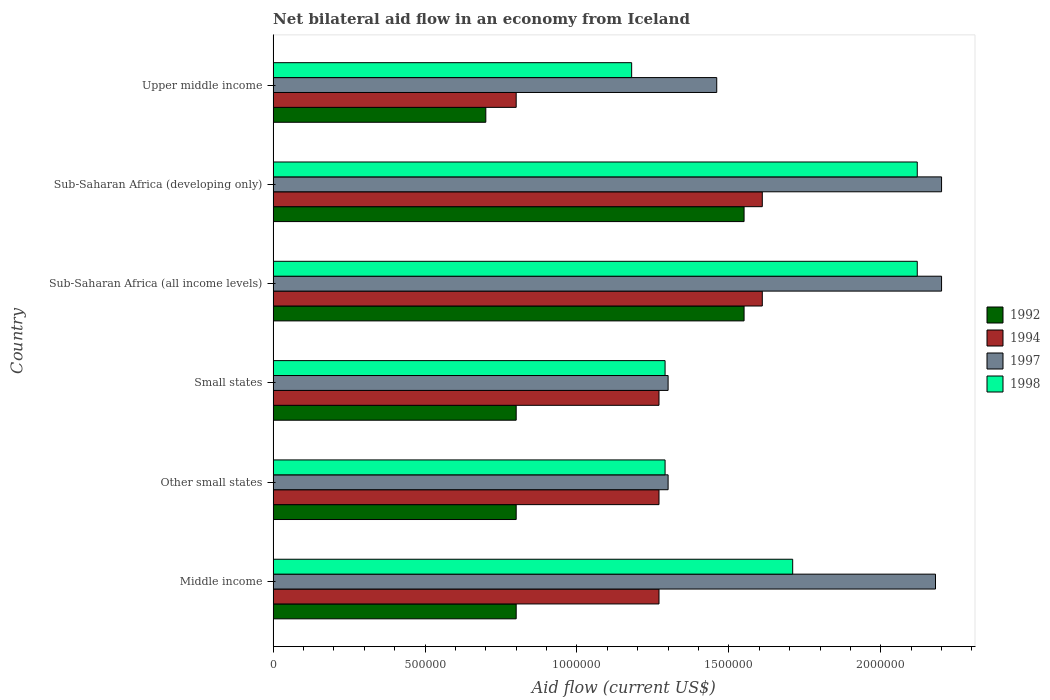How many different coloured bars are there?
Offer a terse response. 4. How many groups of bars are there?
Keep it short and to the point. 6. How many bars are there on the 2nd tick from the top?
Your response must be concise. 4. What is the label of the 6th group of bars from the top?
Your answer should be compact. Middle income. What is the net bilateral aid flow in 1998 in Other small states?
Your answer should be compact. 1.29e+06. Across all countries, what is the maximum net bilateral aid flow in 1994?
Your answer should be very brief. 1.61e+06. In which country was the net bilateral aid flow in 1998 maximum?
Your answer should be very brief. Sub-Saharan Africa (all income levels). In which country was the net bilateral aid flow in 1997 minimum?
Offer a very short reply. Other small states. What is the total net bilateral aid flow in 1998 in the graph?
Your answer should be very brief. 9.71e+06. What is the difference between the net bilateral aid flow in 1992 in Middle income and that in Upper middle income?
Keep it short and to the point. 1.00e+05. What is the difference between the net bilateral aid flow in 1994 in Sub-Saharan Africa (developing only) and the net bilateral aid flow in 1992 in Middle income?
Ensure brevity in your answer.  8.10e+05. What is the average net bilateral aid flow in 1994 per country?
Ensure brevity in your answer.  1.30e+06. What is the difference between the net bilateral aid flow in 1992 and net bilateral aid flow in 1998 in Sub-Saharan Africa (all income levels)?
Ensure brevity in your answer.  -5.70e+05. What is the ratio of the net bilateral aid flow in 1997 in Sub-Saharan Africa (developing only) to that in Upper middle income?
Make the answer very short. 1.51. Is the net bilateral aid flow in 1994 in Other small states less than that in Small states?
Offer a very short reply. No. What is the difference between the highest and the lowest net bilateral aid flow in 1992?
Provide a short and direct response. 8.50e+05. Is it the case that in every country, the sum of the net bilateral aid flow in 1994 and net bilateral aid flow in 1992 is greater than the sum of net bilateral aid flow in 1998 and net bilateral aid flow in 1997?
Keep it short and to the point. No. What does the 2nd bar from the top in Sub-Saharan Africa (all income levels) represents?
Provide a succinct answer. 1997. What does the 1st bar from the bottom in Middle income represents?
Your answer should be very brief. 1992. Is it the case that in every country, the sum of the net bilateral aid flow in 1994 and net bilateral aid flow in 1998 is greater than the net bilateral aid flow in 1992?
Keep it short and to the point. Yes. Are the values on the major ticks of X-axis written in scientific E-notation?
Provide a short and direct response. No. How are the legend labels stacked?
Your answer should be compact. Vertical. What is the title of the graph?
Provide a short and direct response. Net bilateral aid flow in an economy from Iceland. What is the label or title of the X-axis?
Your answer should be very brief. Aid flow (current US$). What is the Aid flow (current US$) of 1992 in Middle income?
Provide a succinct answer. 8.00e+05. What is the Aid flow (current US$) of 1994 in Middle income?
Give a very brief answer. 1.27e+06. What is the Aid flow (current US$) of 1997 in Middle income?
Make the answer very short. 2.18e+06. What is the Aid flow (current US$) in 1998 in Middle income?
Your response must be concise. 1.71e+06. What is the Aid flow (current US$) of 1992 in Other small states?
Make the answer very short. 8.00e+05. What is the Aid flow (current US$) of 1994 in Other small states?
Offer a terse response. 1.27e+06. What is the Aid flow (current US$) of 1997 in Other small states?
Offer a terse response. 1.30e+06. What is the Aid flow (current US$) of 1998 in Other small states?
Keep it short and to the point. 1.29e+06. What is the Aid flow (current US$) in 1992 in Small states?
Offer a very short reply. 8.00e+05. What is the Aid flow (current US$) of 1994 in Small states?
Your answer should be very brief. 1.27e+06. What is the Aid flow (current US$) of 1997 in Small states?
Give a very brief answer. 1.30e+06. What is the Aid flow (current US$) of 1998 in Small states?
Make the answer very short. 1.29e+06. What is the Aid flow (current US$) of 1992 in Sub-Saharan Africa (all income levels)?
Ensure brevity in your answer.  1.55e+06. What is the Aid flow (current US$) in 1994 in Sub-Saharan Africa (all income levels)?
Provide a short and direct response. 1.61e+06. What is the Aid flow (current US$) of 1997 in Sub-Saharan Africa (all income levels)?
Make the answer very short. 2.20e+06. What is the Aid flow (current US$) of 1998 in Sub-Saharan Africa (all income levels)?
Make the answer very short. 2.12e+06. What is the Aid flow (current US$) of 1992 in Sub-Saharan Africa (developing only)?
Offer a terse response. 1.55e+06. What is the Aid flow (current US$) in 1994 in Sub-Saharan Africa (developing only)?
Offer a terse response. 1.61e+06. What is the Aid flow (current US$) in 1997 in Sub-Saharan Africa (developing only)?
Your response must be concise. 2.20e+06. What is the Aid flow (current US$) in 1998 in Sub-Saharan Africa (developing only)?
Ensure brevity in your answer.  2.12e+06. What is the Aid flow (current US$) of 1994 in Upper middle income?
Make the answer very short. 8.00e+05. What is the Aid flow (current US$) in 1997 in Upper middle income?
Offer a very short reply. 1.46e+06. What is the Aid flow (current US$) in 1998 in Upper middle income?
Provide a short and direct response. 1.18e+06. Across all countries, what is the maximum Aid flow (current US$) of 1992?
Your answer should be very brief. 1.55e+06. Across all countries, what is the maximum Aid flow (current US$) in 1994?
Ensure brevity in your answer.  1.61e+06. Across all countries, what is the maximum Aid flow (current US$) of 1997?
Provide a succinct answer. 2.20e+06. Across all countries, what is the maximum Aid flow (current US$) of 1998?
Your answer should be very brief. 2.12e+06. Across all countries, what is the minimum Aid flow (current US$) of 1992?
Your answer should be very brief. 7.00e+05. Across all countries, what is the minimum Aid flow (current US$) of 1997?
Make the answer very short. 1.30e+06. Across all countries, what is the minimum Aid flow (current US$) of 1998?
Your answer should be very brief. 1.18e+06. What is the total Aid flow (current US$) of 1992 in the graph?
Make the answer very short. 6.20e+06. What is the total Aid flow (current US$) in 1994 in the graph?
Ensure brevity in your answer.  7.83e+06. What is the total Aid flow (current US$) in 1997 in the graph?
Offer a terse response. 1.06e+07. What is the total Aid flow (current US$) in 1998 in the graph?
Give a very brief answer. 9.71e+06. What is the difference between the Aid flow (current US$) of 1994 in Middle income and that in Other small states?
Make the answer very short. 0. What is the difference between the Aid flow (current US$) in 1997 in Middle income and that in Other small states?
Give a very brief answer. 8.80e+05. What is the difference between the Aid flow (current US$) in 1998 in Middle income and that in Other small states?
Offer a terse response. 4.20e+05. What is the difference between the Aid flow (current US$) in 1992 in Middle income and that in Small states?
Your response must be concise. 0. What is the difference between the Aid flow (current US$) in 1997 in Middle income and that in Small states?
Ensure brevity in your answer.  8.80e+05. What is the difference between the Aid flow (current US$) in 1992 in Middle income and that in Sub-Saharan Africa (all income levels)?
Your answer should be compact. -7.50e+05. What is the difference between the Aid flow (current US$) of 1998 in Middle income and that in Sub-Saharan Africa (all income levels)?
Provide a short and direct response. -4.10e+05. What is the difference between the Aid flow (current US$) in 1992 in Middle income and that in Sub-Saharan Africa (developing only)?
Provide a succinct answer. -7.50e+05. What is the difference between the Aid flow (current US$) in 1997 in Middle income and that in Sub-Saharan Africa (developing only)?
Provide a succinct answer. -2.00e+04. What is the difference between the Aid flow (current US$) in 1998 in Middle income and that in Sub-Saharan Africa (developing only)?
Your answer should be very brief. -4.10e+05. What is the difference between the Aid flow (current US$) in 1992 in Middle income and that in Upper middle income?
Give a very brief answer. 1.00e+05. What is the difference between the Aid flow (current US$) in 1994 in Middle income and that in Upper middle income?
Make the answer very short. 4.70e+05. What is the difference between the Aid flow (current US$) in 1997 in Middle income and that in Upper middle income?
Provide a short and direct response. 7.20e+05. What is the difference between the Aid flow (current US$) of 1998 in Middle income and that in Upper middle income?
Ensure brevity in your answer.  5.30e+05. What is the difference between the Aid flow (current US$) of 1992 in Other small states and that in Small states?
Your answer should be very brief. 0. What is the difference between the Aid flow (current US$) in 1997 in Other small states and that in Small states?
Your answer should be compact. 0. What is the difference between the Aid flow (current US$) of 1998 in Other small states and that in Small states?
Keep it short and to the point. 0. What is the difference between the Aid flow (current US$) of 1992 in Other small states and that in Sub-Saharan Africa (all income levels)?
Provide a short and direct response. -7.50e+05. What is the difference between the Aid flow (current US$) in 1994 in Other small states and that in Sub-Saharan Africa (all income levels)?
Provide a succinct answer. -3.40e+05. What is the difference between the Aid flow (current US$) of 1997 in Other small states and that in Sub-Saharan Africa (all income levels)?
Ensure brevity in your answer.  -9.00e+05. What is the difference between the Aid flow (current US$) of 1998 in Other small states and that in Sub-Saharan Africa (all income levels)?
Offer a very short reply. -8.30e+05. What is the difference between the Aid flow (current US$) of 1992 in Other small states and that in Sub-Saharan Africa (developing only)?
Your answer should be compact. -7.50e+05. What is the difference between the Aid flow (current US$) of 1997 in Other small states and that in Sub-Saharan Africa (developing only)?
Provide a short and direct response. -9.00e+05. What is the difference between the Aid flow (current US$) in 1998 in Other small states and that in Sub-Saharan Africa (developing only)?
Ensure brevity in your answer.  -8.30e+05. What is the difference between the Aid flow (current US$) of 1997 in Other small states and that in Upper middle income?
Offer a very short reply. -1.60e+05. What is the difference between the Aid flow (current US$) in 1992 in Small states and that in Sub-Saharan Africa (all income levels)?
Offer a very short reply. -7.50e+05. What is the difference between the Aid flow (current US$) of 1994 in Small states and that in Sub-Saharan Africa (all income levels)?
Make the answer very short. -3.40e+05. What is the difference between the Aid flow (current US$) in 1997 in Small states and that in Sub-Saharan Africa (all income levels)?
Keep it short and to the point. -9.00e+05. What is the difference between the Aid flow (current US$) of 1998 in Small states and that in Sub-Saharan Africa (all income levels)?
Ensure brevity in your answer.  -8.30e+05. What is the difference between the Aid flow (current US$) of 1992 in Small states and that in Sub-Saharan Africa (developing only)?
Make the answer very short. -7.50e+05. What is the difference between the Aid flow (current US$) in 1997 in Small states and that in Sub-Saharan Africa (developing only)?
Make the answer very short. -9.00e+05. What is the difference between the Aid flow (current US$) of 1998 in Small states and that in Sub-Saharan Africa (developing only)?
Provide a succinct answer. -8.30e+05. What is the difference between the Aid flow (current US$) of 1994 in Small states and that in Upper middle income?
Your answer should be very brief. 4.70e+05. What is the difference between the Aid flow (current US$) in 1998 in Small states and that in Upper middle income?
Offer a terse response. 1.10e+05. What is the difference between the Aid flow (current US$) in 1994 in Sub-Saharan Africa (all income levels) and that in Sub-Saharan Africa (developing only)?
Provide a short and direct response. 0. What is the difference between the Aid flow (current US$) of 1992 in Sub-Saharan Africa (all income levels) and that in Upper middle income?
Your answer should be compact. 8.50e+05. What is the difference between the Aid flow (current US$) of 1994 in Sub-Saharan Africa (all income levels) and that in Upper middle income?
Your response must be concise. 8.10e+05. What is the difference between the Aid flow (current US$) in 1997 in Sub-Saharan Africa (all income levels) and that in Upper middle income?
Make the answer very short. 7.40e+05. What is the difference between the Aid flow (current US$) of 1998 in Sub-Saharan Africa (all income levels) and that in Upper middle income?
Keep it short and to the point. 9.40e+05. What is the difference between the Aid flow (current US$) of 1992 in Sub-Saharan Africa (developing only) and that in Upper middle income?
Ensure brevity in your answer.  8.50e+05. What is the difference between the Aid flow (current US$) in 1994 in Sub-Saharan Africa (developing only) and that in Upper middle income?
Provide a succinct answer. 8.10e+05. What is the difference between the Aid flow (current US$) in 1997 in Sub-Saharan Africa (developing only) and that in Upper middle income?
Give a very brief answer. 7.40e+05. What is the difference between the Aid flow (current US$) in 1998 in Sub-Saharan Africa (developing only) and that in Upper middle income?
Offer a terse response. 9.40e+05. What is the difference between the Aid flow (current US$) in 1992 in Middle income and the Aid flow (current US$) in 1994 in Other small states?
Ensure brevity in your answer.  -4.70e+05. What is the difference between the Aid flow (current US$) in 1992 in Middle income and the Aid flow (current US$) in 1997 in Other small states?
Ensure brevity in your answer.  -5.00e+05. What is the difference between the Aid flow (current US$) in 1992 in Middle income and the Aid flow (current US$) in 1998 in Other small states?
Ensure brevity in your answer.  -4.90e+05. What is the difference between the Aid flow (current US$) of 1997 in Middle income and the Aid flow (current US$) of 1998 in Other small states?
Offer a very short reply. 8.90e+05. What is the difference between the Aid flow (current US$) of 1992 in Middle income and the Aid flow (current US$) of 1994 in Small states?
Offer a terse response. -4.70e+05. What is the difference between the Aid flow (current US$) of 1992 in Middle income and the Aid flow (current US$) of 1997 in Small states?
Your response must be concise. -5.00e+05. What is the difference between the Aid flow (current US$) of 1992 in Middle income and the Aid flow (current US$) of 1998 in Small states?
Offer a very short reply. -4.90e+05. What is the difference between the Aid flow (current US$) in 1994 in Middle income and the Aid flow (current US$) in 1997 in Small states?
Offer a terse response. -3.00e+04. What is the difference between the Aid flow (current US$) in 1994 in Middle income and the Aid flow (current US$) in 1998 in Small states?
Your answer should be compact. -2.00e+04. What is the difference between the Aid flow (current US$) in 1997 in Middle income and the Aid flow (current US$) in 1998 in Small states?
Your response must be concise. 8.90e+05. What is the difference between the Aid flow (current US$) of 1992 in Middle income and the Aid flow (current US$) of 1994 in Sub-Saharan Africa (all income levels)?
Keep it short and to the point. -8.10e+05. What is the difference between the Aid flow (current US$) of 1992 in Middle income and the Aid flow (current US$) of 1997 in Sub-Saharan Africa (all income levels)?
Ensure brevity in your answer.  -1.40e+06. What is the difference between the Aid flow (current US$) in 1992 in Middle income and the Aid flow (current US$) in 1998 in Sub-Saharan Africa (all income levels)?
Keep it short and to the point. -1.32e+06. What is the difference between the Aid flow (current US$) in 1994 in Middle income and the Aid flow (current US$) in 1997 in Sub-Saharan Africa (all income levels)?
Your response must be concise. -9.30e+05. What is the difference between the Aid flow (current US$) of 1994 in Middle income and the Aid flow (current US$) of 1998 in Sub-Saharan Africa (all income levels)?
Keep it short and to the point. -8.50e+05. What is the difference between the Aid flow (current US$) of 1992 in Middle income and the Aid flow (current US$) of 1994 in Sub-Saharan Africa (developing only)?
Ensure brevity in your answer.  -8.10e+05. What is the difference between the Aid flow (current US$) in 1992 in Middle income and the Aid flow (current US$) in 1997 in Sub-Saharan Africa (developing only)?
Your answer should be compact. -1.40e+06. What is the difference between the Aid flow (current US$) in 1992 in Middle income and the Aid flow (current US$) in 1998 in Sub-Saharan Africa (developing only)?
Your response must be concise. -1.32e+06. What is the difference between the Aid flow (current US$) of 1994 in Middle income and the Aid flow (current US$) of 1997 in Sub-Saharan Africa (developing only)?
Give a very brief answer. -9.30e+05. What is the difference between the Aid flow (current US$) in 1994 in Middle income and the Aid flow (current US$) in 1998 in Sub-Saharan Africa (developing only)?
Keep it short and to the point. -8.50e+05. What is the difference between the Aid flow (current US$) of 1997 in Middle income and the Aid flow (current US$) of 1998 in Sub-Saharan Africa (developing only)?
Make the answer very short. 6.00e+04. What is the difference between the Aid flow (current US$) in 1992 in Middle income and the Aid flow (current US$) in 1997 in Upper middle income?
Keep it short and to the point. -6.60e+05. What is the difference between the Aid flow (current US$) of 1992 in Middle income and the Aid flow (current US$) of 1998 in Upper middle income?
Your response must be concise. -3.80e+05. What is the difference between the Aid flow (current US$) in 1994 in Middle income and the Aid flow (current US$) in 1997 in Upper middle income?
Give a very brief answer. -1.90e+05. What is the difference between the Aid flow (current US$) of 1997 in Middle income and the Aid flow (current US$) of 1998 in Upper middle income?
Offer a very short reply. 1.00e+06. What is the difference between the Aid flow (current US$) of 1992 in Other small states and the Aid flow (current US$) of 1994 in Small states?
Ensure brevity in your answer.  -4.70e+05. What is the difference between the Aid flow (current US$) of 1992 in Other small states and the Aid flow (current US$) of 1997 in Small states?
Provide a succinct answer. -5.00e+05. What is the difference between the Aid flow (current US$) in 1992 in Other small states and the Aid flow (current US$) in 1998 in Small states?
Ensure brevity in your answer.  -4.90e+05. What is the difference between the Aid flow (current US$) in 1994 in Other small states and the Aid flow (current US$) in 1998 in Small states?
Your response must be concise. -2.00e+04. What is the difference between the Aid flow (current US$) of 1992 in Other small states and the Aid flow (current US$) of 1994 in Sub-Saharan Africa (all income levels)?
Provide a short and direct response. -8.10e+05. What is the difference between the Aid flow (current US$) of 1992 in Other small states and the Aid flow (current US$) of 1997 in Sub-Saharan Africa (all income levels)?
Give a very brief answer. -1.40e+06. What is the difference between the Aid flow (current US$) of 1992 in Other small states and the Aid flow (current US$) of 1998 in Sub-Saharan Africa (all income levels)?
Your answer should be compact. -1.32e+06. What is the difference between the Aid flow (current US$) of 1994 in Other small states and the Aid flow (current US$) of 1997 in Sub-Saharan Africa (all income levels)?
Your answer should be compact. -9.30e+05. What is the difference between the Aid flow (current US$) in 1994 in Other small states and the Aid flow (current US$) in 1998 in Sub-Saharan Africa (all income levels)?
Your answer should be very brief. -8.50e+05. What is the difference between the Aid flow (current US$) of 1997 in Other small states and the Aid flow (current US$) of 1998 in Sub-Saharan Africa (all income levels)?
Your answer should be very brief. -8.20e+05. What is the difference between the Aid flow (current US$) in 1992 in Other small states and the Aid flow (current US$) in 1994 in Sub-Saharan Africa (developing only)?
Make the answer very short. -8.10e+05. What is the difference between the Aid flow (current US$) in 1992 in Other small states and the Aid flow (current US$) in 1997 in Sub-Saharan Africa (developing only)?
Ensure brevity in your answer.  -1.40e+06. What is the difference between the Aid flow (current US$) of 1992 in Other small states and the Aid flow (current US$) of 1998 in Sub-Saharan Africa (developing only)?
Provide a short and direct response. -1.32e+06. What is the difference between the Aid flow (current US$) of 1994 in Other small states and the Aid flow (current US$) of 1997 in Sub-Saharan Africa (developing only)?
Provide a succinct answer. -9.30e+05. What is the difference between the Aid flow (current US$) of 1994 in Other small states and the Aid flow (current US$) of 1998 in Sub-Saharan Africa (developing only)?
Provide a succinct answer. -8.50e+05. What is the difference between the Aid flow (current US$) of 1997 in Other small states and the Aid flow (current US$) of 1998 in Sub-Saharan Africa (developing only)?
Offer a very short reply. -8.20e+05. What is the difference between the Aid flow (current US$) in 1992 in Other small states and the Aid flow (current US$) in 1994 in Upper middle income?
Your answer should be compact. 0. What is the difference between the Aid flow (current US$) of 1992 in Other small states and the Aid flow (current US$) of 1997 in Upper middle income?
Your response must be concise. -6.60e+05. What is the difference between the Aid flow (current US$) in 1992 in Other small states and the Aid flow (current US$) in 1998 in Upper middle income?
Your answer should be compact. -3.80e+05. What is the difference between the Aid flow (current US$) in 1994 in Other small states and the Aid flow (current US$) in 1997 in Upper middle income?
Ensure brevity in your answer.  -1.90e+05. What is the difference between the Aid flow (current US$) in 1994 in Other small states and the Aid flow (current US$) in 1998 in Upper middle income?
Provide a succinct answer. 9.00e+04. What is the difference between the Aid flow (current US$) of 1997 in Other small states and the Aid flow (current US$) of 1998 in Upper middle income?
Keep it short and to the point. 1.20e+05. What is the difference between the Aid flow (current US$) in 1992 in Small states and the Aid flow (current US$) in 1994 in Sub-Saharan Africa (all income levels)?
Your response must be concise. -8.10e+05. What is the difference between the Aid flow (current US$) of 1992 in Small states and the Aid flow (current US$) of 1997 in Sub-Saharan Africa (all income levels)?
Give a very brief answer. -1.40e+06. What is the difference between the Aid flow (current US$) in 1992 in Small states and the Aid flow (current US$) in 1998 in Sub-Saharan Africa (all income levels)?
Offer a terse response. -1.32e+06. What is the difference between the Aid flow (current US$) in 1994 in Small states and the Aid flow (current US$) in 1997 in Sub-Saharan Africa (all income levels)?
Keep it short and to the point. -9.30e+05. What is the difference between the Aid flow (current US$) in 1994 in Small states and the Aid flow (current US$) in 1998 in Sub-Saharan Africa (all income levels)?
Your answer should be very brief. -8.50e+05. What is the difference between the Aid flow (current US$) of 1997 in Small states and the Aid flow (current US$) of 1998 in Sub-Saharan Africa (all income levels)?
Your response must be concise. -8.20e+05. What is the difference between the Aid flow (current US$) in 1992 in Small states and the Aid flow (current US$) in 1994 in Sub-Saharan Africa (developing only)?
Provide a short and direct response. -8.10e+05. What is the difference between the Aid flow (current US$) of 1992 in Small states and the Aid flow (current US$) of 1997 in Sub-Saharan Africa (developing only)?
Provide a succinct answer. -1.40e+06. What is the difference between the Aid flow (current US$) of 1992 in Small states and the Aid flow (current US$) of 1998 in Sub-Saharan Africa (developing only)?
Offer a very short reply. -1.32e+06. What is the difference between the Aid flow (current US$) of 1994 in Small states and the Aid flow (current US$) of 1997 in Sub-Saharan Africa (developing only)?
Your answer should be compact. -9.30e+05. What is the difference between the Aid flow (current US$) in 1994 in Small states and the Aid flow (current US$) in 1998 in Sub-Saharan Africa (developing only)?
Offer a terse response. -8.50e+05. What is the difference between the Aid flow (current US$) of 1997 in Small states and the Aid flow (current US$) of 1998 in Sub-Saharan Africa (developing only)?
Give a very brief answer. -8.20e+05. What is the difference between the Aid flow (current US$) in 1992 in Small states and the Aid flow (current US$) in 1997 in Upper middle income?
Provide a short and direct response. -6.60e+05. What is the difference between the Aid flow (current US$) of 1992 in Small states and the Aid flow (current US$) of 1998 in Upper middle income?
Offer a very short reply. -3.80e+05. What is the difference between the Aid flow (current US$) of 1994 in Small states and the Aid flow (current US$) of 1998 in Upper middle income?
Provide a short and direct response. 9.00e+04. What is the difference between the Aid flow (current US$) of 1997 in Small states and the Aid flow (current US$) of 1998 in Upper middle income?
Your answer should be compact. 1.20e+05. What is the difference between the Aid flow (current US$) in 1992 in Sub-Saharan Africa (all income levels) and the Aid flow (current US$) in 1994 in Sub-Saharan Africa (developing only)?
Offer a very short reply. -6.00e+04. What is the difference between the Aid flow (current US$) in 1992 in Sub-Saharan Africa (all income levels) and the Aid flow (current US$) in 1997 in Sub-Saharan Africa (developing only)?
Ensure brevity in your answer.  -6.50e+05. What is the difference between the Aid flow (current US$) of 1992 in Sub-Saharan Africa (all income levels) and the Aid flow (current US$) of 1998 in Sub-Saharan Africa (developing only)?
Give a very brief answer. -5.70e+05. What is the difference between the Aid flow (current US$) in 1994 in Sub-Saharan Africa (all income levels) and the Aid flow (current US$) in 1997 in Sub-Saharan Africa (developing only)?
Give a very brief answer. -5.90e+05. What is the difference between the Aid flow (current US$) of 1994 in Sub-Saharan Africa (all income levels) and the Aid flow (current US$) of 1998 in Sub-Saharan Africa (developing only)?
Give a very brief answer. -5.10e+05. What is the difference between the Aid flow (current US$) of 1992 in Sub-Saharan Africa (all income levels) and the Aid flow (current US$) of 1994 in Upper middle income?
Your answer should be very brief. 7.50e+05. What is the difference between the Aid flow (current US$) in 1992 in Sub-Saharan Africa (all income levels) and the Aid flow (current US$) in 1997 in Upper middle income?
Your answer should be compact. 9.00e+04. What is the difference between the Aid flow (current US$) in 1992 in Sub-Saharan Africa (all income levels) and the Aid flow (current US$) in 1998 in Upper middle income?
Offer a terse response. 3.70e+05. What is the difference between the Aid flow (current US$) in 1994 in Sub-Saharan Africa (all income levels) and the Aid flow (current US$) in 1997 in Upper middle income?
Keep it short and to the point. 1.50e+05. What is the difference between the Aid flow (current US$) in 1994 in Sub-Saharan Africa (all income levels) and the Aid flow (current US$) in 1998 in Upper middle income?
Give a very brief answer. 4.30e+05. What is the difference between the Aid flow (current US$) of 1997 in Sub-Saharan Africa (all income levels) and the Aid flow (current US$) of 1998 in Upper middle income?
Provide a short and direct response. 1.02e+06. What is the difference between the Aid flow (current US$) of 1992 in Sub-Saharan Africa (developing only) and the Aid flow (current US$) of 1994 in Upper middle income?
Your answer should be compact. 7.50e+05. What is the difference between the Aid flow (current US$) in 1992 in Sub-Saharan Africa (developing only) and the Aid flow (current US$) in 1998 in Upper middle income?
Offer a terse response. 3.70e+05. What is the difference between the Aid flow (current US$) of 1994 in Sub-Saharan Africa (developing only) and the Aid flow (current US$) of 1997 in Upper middle income?
Offer a very short reply. 1.50e+05. What is the difference between the Aid flow (current US$) of 1994 in Sub-Saharan Africa (developing only) and the Aid flow (current US$) of 1998 in Upper middle income?
Your response must be concise. 4.30e+05. What is the difference between the Aid flow (current US$) of 1997 in Sub-Saharan Africa (developing only) and the Aid flow (current US$) of 1998 in Upper middle income?
Offer a very short reply. 1.02e+06. What is the average Aid flow (current US$) in 1992 per country?
Your answer should be very brief. 1.03e+06. What is the average Aid flow (current US$) in 1994 per country?
Offer a very short reply. 1.30e+06. What is the average Aid flow (current US$) of 1997 per country?
Give a very brief answer. 1.77e+06. What is the average Aid flow (current US$) of 1998 per country?
Offer a terse response. 1.62e+06. What is the difference between the Aid flow (current US$) of 1992 and Aid flow (current US$) of 1994 in Middle income?
Your response must be concise. -4.70e+05. What is the difference between the Aid flow (current US$) of 1992 and Aid flow (current US$) of 1997 in Middle income?
Keep it short and to the point. -1.38e+06. What is the difference between the Aid flow (current US$) in 1992 and Aid flow (current US$) in 1998 in Middle income?
Your response must be concise. -9.10e+05. What is the difference between the Aid flow (current US$) of 1994 and Aid flow (current US$) of 1997 in Middle income?
Give a very brief answer. -9.10e+05. What is the difference between the Aid flow (current US$) of 1994 and Aid flow (current US$) of 1998 in Middle income?
Provide a short and direct response. -4.40e+05. What is the difference between the Aid flow (current US$) of 1997 and Aid flow (current US$) of 1998 in Middle income?
Make the answer very short. 4.70e+05. What is the difference between the Aid flow (current US$) in 1992 and Aid flow (current US$) in 1994 in Other small states?
Offer a terse response. -4.70e+05. What is the difference between the Aid flow (current US$) in 1992 and Aid flow (current US$) in 1997 in Other small states?
Ensure brevity in your answer.  -5.00e+05. What is the difference between the Aid flow (current US$) of 1992 and Aid flow (current US$) of 1998 in Other small states?
Your response must be concise. -4.90e+05. What is the difference between the Aid flow (current US$) of 1997 and Aid flow (current US$) of 1998 in Other small states?
Make the answer very short. 10000. What is the difference between the Aid flow (current US$) of 1992 and Aid flow (current US$) of 1994 in Small states?
Provide a short and direct response. -4.70e+05. What is the difference between the Aid flow (current US$) of 1992 and Aid flow (current US$) of 1997 in Small states?
Offer a very short reply. -5.00e+05. What is the difference between the Aid flow (current US$) in 1992 and Aid flow (current US$) in 1998 in Small states?
Give a very brief answer. -4.90e+05. What is the difference between the Aid flow (current US$) in 1994 and Aid flow (current US$) in 1997 in Small states?
Provide a succinct answer. -3.00e+04. What is the difference between the Aid flow (current US$) in 1994 and Aid flow (current US$) in 1998 in Small states?
Keep it short and to the point. -2.00e+04. What is the difference between the Aid flow (current US$) of 1992 and Aid flow (current US$) of 1997 in Sub-Saharan Africa (all income levels)?
Provide a succinct answer. -6.50e+05. What is the difference between the Aid flow (current US$) of 1992 and Aid flow (current US$) of 1998 in Sub-Saharan Africa (all income levels)?
Keep it short and to the point. -5.70e+05. What is the difference between the Aid flow (current US$) of 1994 and Aid flow (current US$) of 1997 in Sub-Saharan Africa (all income levels)?
Offer a terse response. -5.90e+05. What is the difference between the Aid flow (current US$) in 1994 and Aid flow (current US$) in 1998 in Sub-Saharan Africa (all income levels)?
Make the answer very short. -5.10e+05. What is the difference between the Aid flow (current US$) in 1992 and Aid flow (current US$) in 1997 in Sub-Saharan Africa (developing only)?
Make the answer very short. -6.50e+05. What is the difference between the Aid flow (current US$) of 1992 and Aid flow (current US$) of 1998 in Sub-Saharan Africa (developing only)?
Your answer should be compact. -5.70e+05. What is the difference between the Aid flow (current US$) in 1994 and Aid flow (current US$) in 1997 in Sub-Saharan Africa (developing only)?
Keep it short and to the point. -5.90e+05. What is the difference between the Aid flow (current US$) in 1994 and Aid flow (current US$) in 1998 in Sub-Saharan Africa (developing only)?
Your response must be concise. -5.10e+05. What is the difference between the Aid flow (current US$) of 1997 and Aid flow (current US$) of 1998 in Sub-Saharan Africa (developing only)?
Your answer should be compact. 8.00e+04. What is the difference between the Aid flow (current US$) in 1992 and Aid flow (current US$) in 1997 in Upper middle income?
Your response must be concise. -7.60e+05. What is the difference between the Aid flow (current US$) in 1992 and Aid flow (current US$) in 1998 in Upper middle income?
Offer a very short reply. -4.80e+05. What is the difference between the Aid flow (current US$) in 1994 and Aid flow (current US$) in 1997 in Upper middle income?
Your answer should be compact. -6.60e+05. What is the difference between the Aid flow (current US$) of 1994 and Aid flow (current US$) of 1998 in Upper middle income?
Give a very brief answer. -3.80e+05. What is the ratio of the Aid flow (current US$) in 1992 in Middle income to that in Other small states?
Ensure brevity in your answer.  1. What is the ratio of the Aid flow (current US$) in 1997 in Middle income to that in Other small states?
Keep it short and to the point. 1.68. What is the ratio of the Aid flow (current US$) of 1998 in Middle income to that in Other small states?
Keep it short and to the point. 1.33. What is the ratio of the Aid flow (current US$) of 1992 in Middle income to that in Small states?
Your answer should be compact. 1. What is the ratio of the Aid flow (current US$) in 1994 in Middle income to that in Small states?
Provide a succinct answer. 1. What is the ratio of the Aid flow (current US$) of 1997 in Middle income to that in Small states?
Provide a succinct answer. 1.68. What is the ratio of the Aid flow (current US$) of 1998 in Middle income to that in Small states?
Provide a short and direct response. 1.33. What is the ratio of the Aid flow (current US$) in 1992 in Middle income to that in Sub-Saharan Africa (all income levels)?
Ensure brevity in your answer.  0.52. What is the ratio of the Aid flow (current US$) of 1994 in Middle income to that in Sub-Saharan Africa (all income levels)?
Make the answer very short. 0.79. What is the ratio of the Aid flow (current US$) in 1997 in Middle income to that in Sub-Saharan Africa (all income levels)?
Keep it short and to the point. 0.99. What is the ratio of the Aid flow (current US$) in 1998 in Middle income to that in Sub-Saharan Africa (all income levels)?
Make the answer very short. 0.81. What is the ratio of the Aid flow (current US$) of 1992 in Middle income to that in Sub-Saharan Africa (developing only)?
Offer a very short reply. 0.52. What is the ratio of the Aid flow (current US$) in 1994 in Middle income to that in Sub-Saharan Africa (developing only)?
Give a very brief answer. 0.79. What is the ratio of the Aid flow (current US$) in 1997 in Middle income to that in Sub-Saharan Africa (developing only)?
Keep it short and to the point. 0.99. What is the ratio of the Aid flow (current US$) in 1998 in Middle income to that in Sub-Saharan Africa (developing only)?
Your response must be concise. 0.81. What is the ratio of the Aid flow (current US$) of 1992 in Middle income to that in Upper middle income?
Offer a terse response. 1.14. What is the ratio of the Aid flow (current US$) in 1994 in Middle income to that in Upper middle income?
Keep it short and to the point. 1.59. What is the ratio of the Aid flow (current US$) of 1997 in Middle income to that in Upper middle income?
Your answer should be very brief. 1.49. What is the ratio of the Aid flow (current US$) in 1998 in Middle income to that in Upper middle income?
Your answer should be compact. 1.45. What is the ratio of the Aid flow (current US$) in 1992 in Other small states to that in Small states?
Offer a very short reply. 1. What is the ratio of the Aid flow (current US$) of 1997 in Other small states to that in Small states?
Ensure brevity in your answer.  1. What is the ratio of the Aid flow (current US$) in 1998 in Other small states to that in Small states?
Provide a succinct answer. 1. What is the ratio of the Aid flow (current US$) in 1992 in Other small states to that in Sub-Saharan Africa (all income levels)?
Provide a succinct answer. 0.52. What is the ratio of the Aid flow (current US$) of 1994 in Other small states to that in Sub-Saharan Africa (all income levels)?
Give a very brief answer. 0.79. What is the ratio of the Aid flow (current US$) of 1997 in Other small states to that in Sub-Saharan Africa (all income levels)?
Your response must be concise. 0.59. What is the ratio of the Aid flow (current US$) in 1998 in Other small states to that in Sub-Saharan Africa (all income levels)?
Make the answer very short. 0.61. What is the ratio of the Aid flow (current US$) of 1992 in Other small states to that in Sub-Saharan Africa (developing only)?
Your answer should be very brief. 0.52. What is the ratio of the Aid flow (current US$) of 1994 in Other small states to that in Sub-Saharan Africa (developing only)?
Ensure brevity in your answer.  0.79. What is the ratio of the Aid flow (current US$) in 1997 in Other small states to that in Sub-Saharan Africa (developing only)?
Your answer should be very brief. 0.59. What is the ratio of the Aid flow (current US$) in 1998 in Other small states to that in Sub-Saharan Africa (developing only)?
Your response must be concise. 0.61. What is the ratio of the Aid flow (current US$) of 1992 in Other small states to that in Upper middle income?
Give a very brief answer. 1.14. What is the ratio of the Aid flow (current US$) in 1994 in Other small states to that in Upper middle income?
Make the answer very short. 1.59. What is the ratio of the Aid flow (current US$) of 1997 in Other small states to that in Upper middle income?
Offer a terse response. 0.89. What is the ratio of the Aid flow (current US$) of 1998 in Other small states to that in Upper middle income?
Ensure brevity in your answer.  1.09. What is the ratio of the Aid flow (current US$) of 1992 in Small states to that in Sub-Saharan Africa (all income levels)?
Provide a short and direct response. 0.52. What is the ratio of the Aid flow (current US$) in 1994 in Small states to that in Sub-Saharan Africa (all income levels)?
Your answer should be compact. 0.79. What is the ratio of the Aid flow (current US$) in 1997 in Small states to that in Sub-Saharan Africa (all income levels)?
Give a very brief answer. 0.59. What is the ratio of the Aid flow (current US$) of 1998 in Small states to that in Sub-Saharan Africa (all income levels)?
Make the answer very short. 0.61. What is the ratio of the Aid flow (current US$) of 1992 in Small states to that in Sub-Saharan Africa (developing only)?
Provide a short and direct response. 0.52. What is the ratio of the Aid flow (current US$) in 1994 in Small states to that in Sub-Saharan Africa (developing only)?
Offer a very short reply. 0.79. What is the ratio of the Aid flow (current US$) of 1997 in Small states to that in Sub-Saharan Africa (developing only)?
Ensure brevity in your answer.  0.59. What is the ratio of the Aid flow (current US$) in 1998 in Small states to that in Sub-Saharan Africa (developing only)?
Make the answer very short. 0.61. What is the ratio of the Aid flow (current US$) in 1992 in Small states to that in Upper middle income?
Provide a short and direct response. 1.14. What is the ratio of the Aid flow (current US$) of 1994 in Small states to that in Upper middle income?
Your answer should be very brief. 1.59. What is the ratio of the Aid flow (current US$) of 1997 in Small states to that in Upper middle income?
Provide a short and direct response. 0.89. What is the ratio of the Aid flow (current US$) of 1998 in Small states to that in Upper middle income?
Your answer should be compact. 1.09. What is the ratio of the Aid flow (current US$) of 1992 in Sub-Saharan Africa (all income levels) to that in Sub-Saharan Africa (developing only)?
Provide a succinct answer. 1. What is the ratio of the Aid flow (current US$) of 1997 in Sub-Saharan Africa (all income levels) to that in Sub-Saharan Africa (developing only)?
Your answer should be very brief. 1. What is the ratio of the Aid flow (current US$) of 1998 in Sub-Saharan Africa (all income levels) to that in Sub-Saharan Africa (developing only)?
Your answer should be compact. 1. What is the ratio of the Aid flow (current US$) of 1992 in Sub-Saharan Africa (all income levels) to that in Upper middle income?
Provide a short and direct response. 2.21. What is the ratio of the Aid flow (current US$) of 1994 in Sub-Saharan Africa (all income levels) to that in Upper middle income?
Offer a terse response. 2.01. What is the ratio of the Aid flow (current US$) of 1997 in Sub-Saharan Africa (all income levels) to that in Upper middle income?
Provide a succinct answer. 1.51. What is the ratio of the Aid flow (current US$) in 1998 in Sub-Saharan Africa (all income levels) to that in Upper middle income?
Your answer should be compact. 1.8. What is the ratio of the Aid flow (current US$) of 1992 in Sub-Saharan Africa (developing only) to that in Upper middle income?
Make the answer very short. 2.21. What is the ratio of the Aid flow (current US$) in 1994 in Sub-Saharan Africa (developing only) to that in Upper middle income?
Keep it short and to the point. 2.01. What is the ratio of the Aid flow (current US$) of 1997 in Sub-Saharan Africa (developing only) to that in Upper middle income?
Your answer should be very brief. 1.51. What is the ratio of the Aid flow (current US$) of 1998 in Sub-Saharan Africa (developing only) to that in Upper middle income?
Give a very brief answer. 1.8. What is the difference between the highest and the second highest Aid flow (current US$) of 1997?
Make the answer very short. 0. What is the difference between the highest and the second highest Aid flow (current US$) of 1998?
Your answer should be compact. 0. What is the difference between the highest and the lowest Aid flow (current US$) of 1992?
Your answer should be compact. 8.50e+05. What is the difference between the highest and the lowest Aid flow (current US$) of 1994?
Offer a very short reply. 8.10e+05. What is the difference between the highest and the lowest Aid flow (current US$) of 1997?
Provide a short and direct response. 9.00e+05. What is the difference between the highest and the lowest Aid flow (current US$) of 1998?
Give a very brief answer. 9.40e+05. 